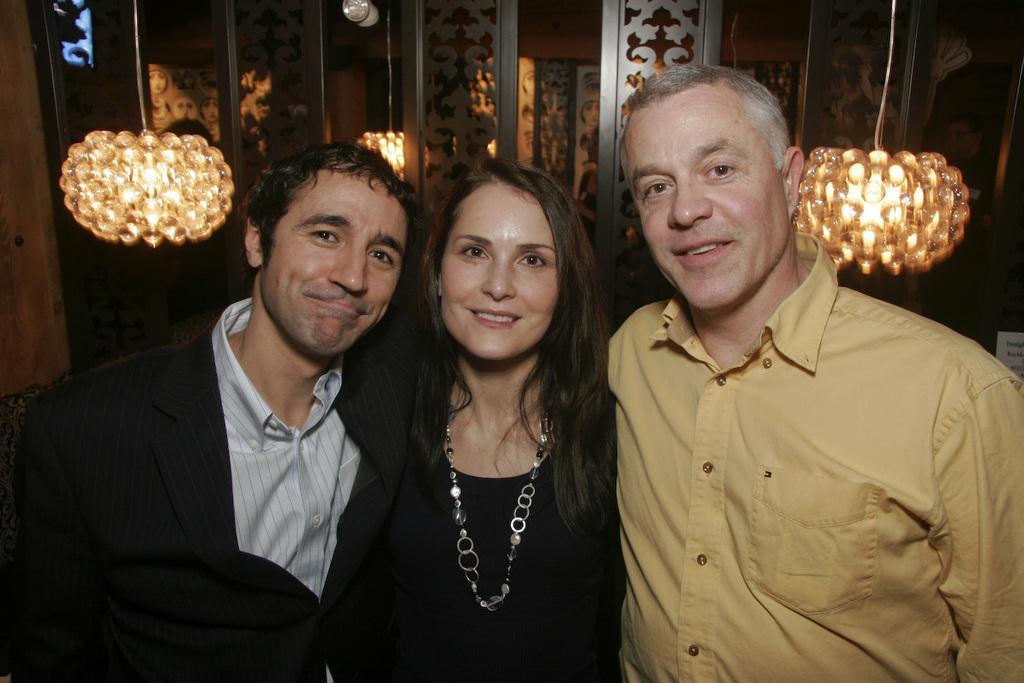In one or two sentences, can you explain what this image depicts? In this image there are three people standing with a smile on their face, In the background there is a wall and few lamps are hanging. 